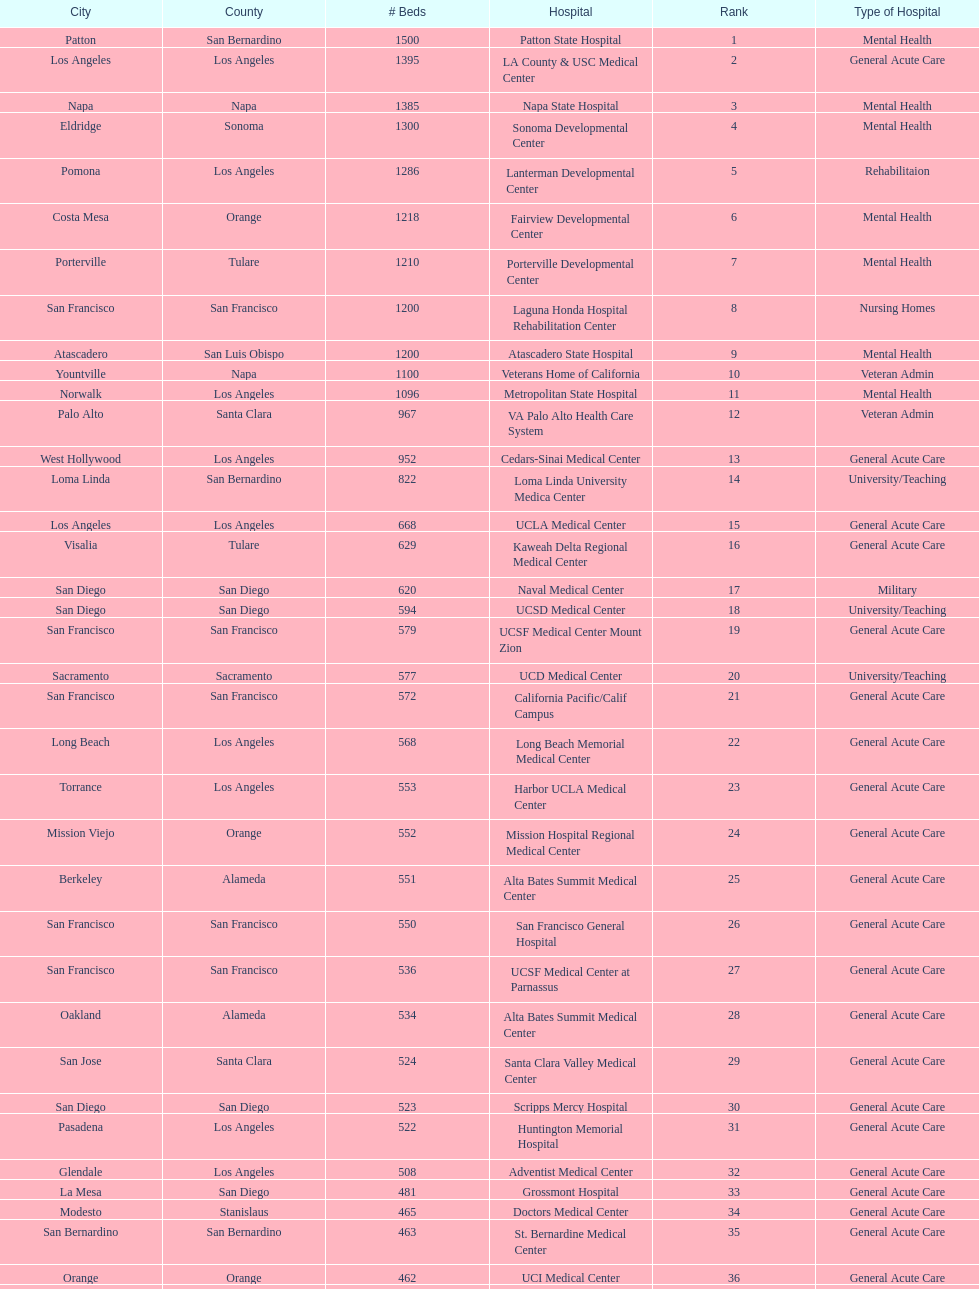Parse the table in full. {'header': ['City', 'County', '# Beds', 'Hospital', 'Rank', 'Type of Hospital'], 'rows': [['Patton', 'San Bernardino', '1500', 'Patton State Hospital', '1', 'Mental Health'], ['Los Angeles', 'Los Angeles', '1395', 'LA County & USC Medical Center', '2', 'General Acute Care'], ['Napa', 'Napa', '1385', 'Napa State Hospital', '3', 'Mental Health'], ['Eldridge', 'Sonoma', '1300', 'Sonoma Developmental Center', '4', 'Mental Health'], ['Pomona', 'Los Angeles', '1286', 'Lanterman Developmental Center', '5', 'Rehabilitaion'], ['Costa Mesa', 'Orange', '1218', 'Fairview Developmental Center', '6', 'Mental Health'], ['Porterville', 'Tulare', '1210', 'Porterville Developmental Center', '7', 'Mental Health'], ['San Francisco', 'San Francisco', '1200', 'Laguna Honda Hospital Rehabilitation Center', '8', 'Nursing Homes'], ['Atascadero', 'San Luis Obispo', '1200', 'Atascadero State Hospital', '9', 'Mental Health'], ['Yountville', 'Napa', '1100', 'Veterans Home of California', '10', 'Veteran Admin'], ['Norwalk', 'Los Angeles', '1096', 'Metropolitan State Hospital', '11', 'Mental Health'], ['Palo Alto', 'Santa Clara', '967', 'VA Palo Alto Health Care System', '12', 'Veteran Admin'], ['West Hollywood', 'Los Angeles', '952', 'Cedars-Sinai Medical Center', '13', 'General Acute Care'], ['Loma Linda', 'San Bernardino', '822', 'Loma Linda University Medica Center', '14', 'University/Teaching'], ['Los Angeles', 'Los Angeles', '668', 'UCLA Medical Center', '15', 'General Acute Care'], ['Visalia', 'Tulare', '629', 'Kaweah Delta Regional Medical Center', '16', 'General Acute Care'], ['San Diego', 'San Diego', '620', 'Naval Medical Center', '17', 'Military'], ['San Diego', 'San Diego', '594', 'UCSD Medical Center', '18', 'University/Teaching'], ['San Francisco', 'San Francisco', '579', 'UCSF Medical Center Mount Zion', '19', 'General Acute Care'], ['Sacramento', 'Sacramento', '577', 'UCD Medical Center', '20', 'University/Teaching'], ['San Francisco', 'San Francisco', '572', 'California Pacific/Calif Campus', '21', 'General Acute Care'], ['Long Beach', 'Los Angeles', '568', 'Long Beach Memorial Medical Center', '22', 'General Acute Care'], ['Torrance', 'Los Angeles', '553', 'Harbor UCLA Medical Center', '23', 'General Acute Care'], ['Mission Viejo', 'Orange', '552', 'Mission Hospital Regional Medical Center', '24', 'General Acute Care'], ['Berkeley', 'Alameda', '551', 'Alta Bates Summit Medical Center', '25', 'General Acute Care'], ['San Francisco', 'San Francisco', '550', 'San Francisco General Hospital', '26', 'General Acute Care'], ['San Francisco', 'San Francisco', '536', 'UCSF Medical Center at Parnassus', '27', 'General Acute Care'], ['Oakland', 'Alameda', '534', 'Alta Bates Summit Medical Center', '28', 'General Acute Care'], ['San Jose', 'Santa Clara', '524', 'Santa Clara Valley Medical Center', '29', 'General Acute Care'], ['San Diego', 'San Diego', '523', 'Scripps Mercy Hospital', '30', 'General Acute Care'], ['Pasadena', 'Los Angeles', '522', 'Huntington Memorial Hospital', '31', 'General Acute Care'], ['Glendale', 'Los Angeles', '508', 'Adventist Medical Center', '32', 'General Acute Care'], ['La Mesa', 'San Diego', '481', 'Grossmont Hospital', '33', 'General Acute Care'], ['Modesto', 'Stanislaus', '465', 'Doctors Medical Center', '34', 'General Acute Care'], ['San Bernardino', 'San Bernardino', '463', 'St. Bernardine Medical Center', '35', 'General Acute Care'], ['Orange', 'Orange', '462', 'UCI Medical Center', '36', 'General Acute Care'], ['Stanford', 'Santa Clara', '460', 'Stanford Medical Center', '37', 'General Acute Care'], ['Fresno', 'Fresno', '457', 'Community Regional Medical Center', '38', 'General Acute Care'], ['Arcadia', 'Los Angeles', '455', 'Methodist Hospital', '39', 'General Acute Care'], ['Burbank', 'Los Angeles', '455', 'Providence St. Joseph Medical Center', '40', 'General Acute Care'], ['Newport Beach', 'Orange', '450', 'Hoag Memorial Hospital', '41', 'General Acute Care'], ['San Jose', 'Santa Clara', '450', 'Agnews Developmental Center', '42', 'Mental Health'], ['San Francisco', 'San Francisco', '450', 'Jewish Home', '43', 'Nursing Homes'], ['Orange', 'Orange', '448', 'St. Joseph Hospital Orange', '44', 'General Acute Care'], ['Whittier', 'Los Angeles', '441', 'Presbyterian Intercommunity', '45', 'General Acute Care'], ['Fontana', 'San Bernardino', '440', 'Kaiser Permanente Medical Center', '46', 'General Acute Care'], ['Los Angeles', 'Los Angeles', '439', 'Kaiser Permanente Medical Center', '47', 'General Acute Care'], ['Pomona', 'Los Angeles', '436', 'Pomona Valley Hospital Medical Center', '48', 'General Acute Care'], ['Sacramento', 'Sacramento', '432', 'Sutter General Medical Center', '49', 'General Acute Care'], ['San Francisco', 'San Francisco', '430', 'St. Mary Medical Center', '50', 'General Acute Care'], ['San Jose', 'Santa Clara', '429', 'Good Samaritan Hospital', '50', 'General Acute Care']]} How many more general acute care hospitals are there in california than rehabilitation hospitals? 33. 